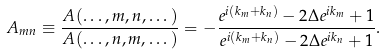<formula> <loc_0><loc_0><loc_500><loc_500>A _ { m n } \equiv \frac { A ( \dots , m , n , \dots ) } { A ( \dots , n , m , \dots ) } = - \frac { e ^ { i ( k _ { m } + k _ { n } ) } - 2 \Delta e ^ { i k _ { m } } + 1 } { e ^ { i ( k _ { m } + k _ { n } ) } - 2 \Delta e ^ { i k _ { n } } + 1 } .</formula> 